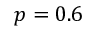Convert formula to latex. <formula><loc_0><loc_0><loc_500><loc_500>p = 0 . 6</formula> 